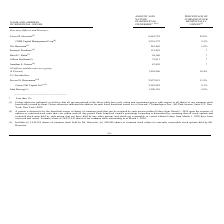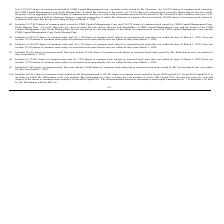According to Network 1 Technologies's financial document, How is the percentage ownership of common stock determined? by assuming that all stock options and restricted stock units held by such person (but not those held by any other person) and which are exercisable or vested within 60 days from March 1, 2020 have been exercised and vested.. The document states: "eficial owner's percentage ownership is determined by assuming that all stock options and restricted stock units held by such person (but not those he..." Also, What is the total amount and nature of beneficial ownership for all officers and directors as a group? According to the financial document, 7,458,266. The relevant text states: "All officers and directors as a group (6 Persons) 7,458,266 30.4%..." Also, Who is the sole member of CMH Capital Management Corp. and who is the sole member of Goose Hill Capital LLC.? The document shows two values: Corey M. Horowitz and Mr. Heinemann. From the document: "Corey M. Horowitz (3) 6,862,752 28.0% Includes 585,233 shares of common stock owned by Mr. Heinemann and 2,242,582 shares of common stock owned by Goo..." Also, How many executive officers and directors own less than 100,000 in nature of beneficial ownership? Counting the relevant items in the document: David C. Kahn, Allison Hoffman, Jonathan E. Greene, I find 3 instances. The key data points involved are: Allison Hoffman, David C. Kahn, Jonathan E. Greene. Also, can you calculate: What is the percentage of amount and nature of beneficial ownership for John Herzog among the 5% Stockholders? To answer this question, I need to perform calculations using the financial data. The calculation is: 1,200,130 / (1,200,130 + 2,242,582 + 2,827,815)  , which equals 19.14 (percentage). This is based on the information: "John Herzog (12) 1,200,130 5.0% Steven D. Heinemann (10) 2,827,815 11.8% Goose Hill Capital LLC (11) 2,242,582 9.3%..." The key data points involved are: 1,200,130, 2,242,582, 2,827,815. Also, can you calculate: How much more do all officers and directors as a group have in amount and nature of beneficial ownership as compared to the 5% Stockholders? Based on the calculation: 7,458,266 - (1,200,130 + 2,242,582 + 2,827,815)  , the result is 1187739. This is based on the information: "John Herzog (12) 1,200,130 5.0% All officers and directors as a group (6 Persons) 7,458,266 30.4% Steven D. Heinemann (10) 2,827,815 11.8% Goose Hill Capital LLC (11) 2,242,582 9.3%..." The key data points involved are: 1,200,130, 2,242,582, 2,827,815. 